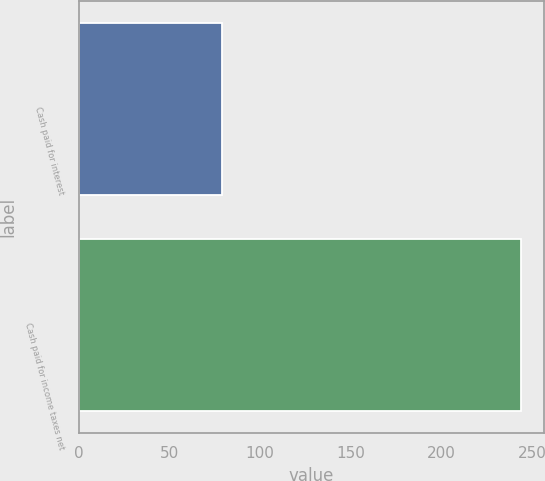Convert chart to OTSL. <chart><loc_0><loc_0><loc_500><loc_500><bar_chart><fcel>Cash paid for interest<fcel>Cash paid for income taxes net<nl><fcel>78.8<fcel>244.1<nl></chart> 